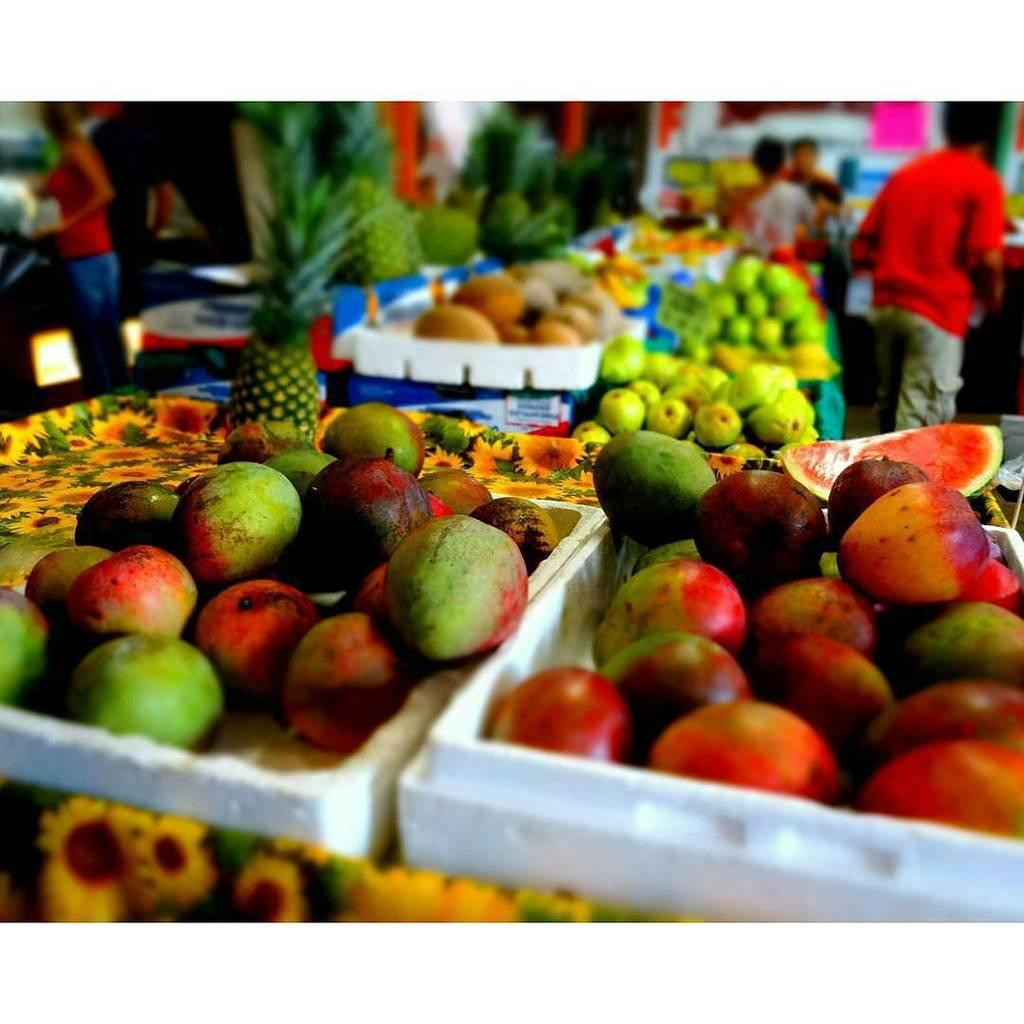What is present in the tray that is visible in the image? There are fruits in a tray in the image. What can be seen on the floor in the image? There are people standing on the floor in the image. How many tails can be seen on the cows in the image? There are no cows present in the image, so there are no tails to count. 